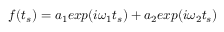<formula> <loc_0><loc_0><loc_500><loc_500>\begin{array} { r } { f ( t _ { s } ) = a _ { 1 } e x p ( i \omega _ { 1 } t _ { s } ) + a _ { 2 } e x p ( i \omega _ { 2 } t _ { s } ) } \end{array}</formula> 